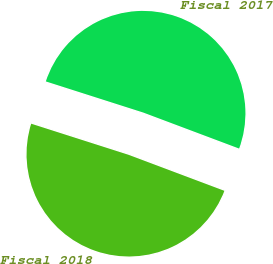Convert chart to OTSL. <chart><loc_0><loc_0><loc_500><loc_500><pie_chart><fcel>Fiscal 2017<fcel>Fiscal 2018<nl><fcel>50.8%<fcel>49.2%<nl></chart> 